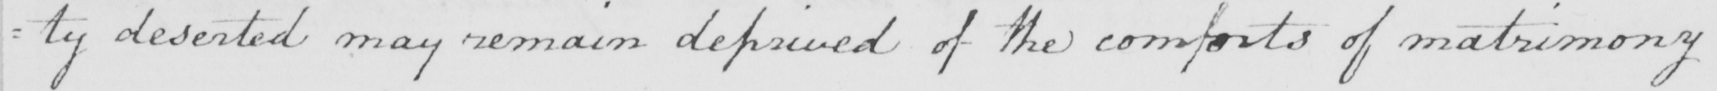What does this handwritten line say? =ty deserted may remain deprived of the comforts of matrimony 